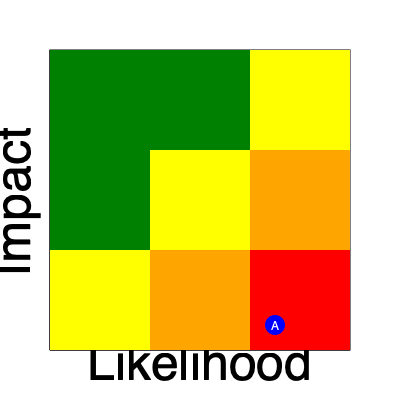As department chief, you're evaluating a new project with potential cybersecurity risks. The heat map shows the current risk assessment for a critical vulnerability (Point A). What immediate action should you recommend to your team based on this analysis? To answer this question, we need to interpret the heat map and understand its implications for risk management:

1. Interpret the heat map:
   - The x-axis represents the likelihood of an event occurring.
   - The y-axis represents the impact of the event.
   - Colors indicate risk levels: Green (low), Yellow (medium), Orange (high), Red (critical).

2. Locate Point A:
   - Point A is in the top-right corner of the heat map.
   - This position indicates high likelihood and high impact.

3. Assess the risk level:
   - Point A is in the red zone, which represents critical risk.

4. Understand the implications:
   - Critical risks require immediate attention and action.
   - Delaying mitigation could lead to severe consequences for the department.

5. Determine appropriate action:
   - For critical risks, the priority is to implement immediate risk mitigation strategies.
   - This may involve deploying urgent security patches, implementing additional controls, or even temporarily shutting down affected systems until the vulnerability can be addressed.

6. Consider the department chief perspective:
   - As a department chief, your primary concern is protecting the organization from high-impact threats.
   - Immediate action is necessary to reduce the risk to an acceptable level.

Given the critical nature of the risk, the most appropriate immediate action is to implement urgent risk mitigation strategies to reduce either the likelihood or impact of the vulnerability, or both if possible.
Answer: Implement urgent risk mitigation strategies 